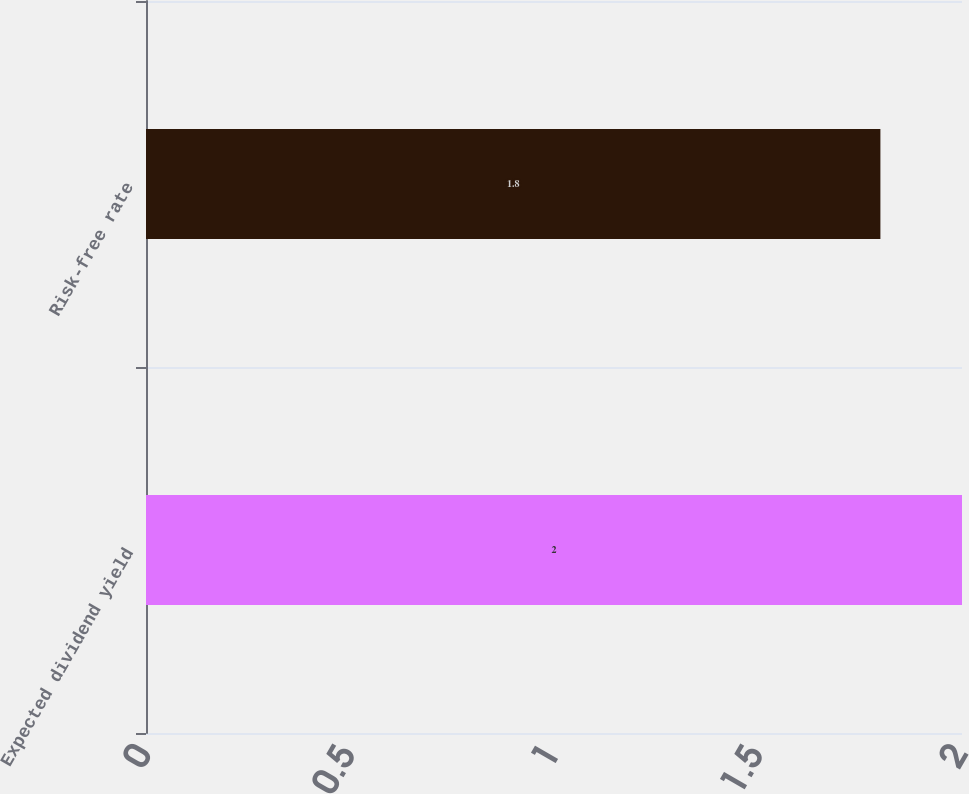<chart> <loc_0><loc_0><loc_500><loc_500><bar_chart><fcel>Expected dividend yield<fcel>Risk-free rate<nl><fcel>2<fcel>1.8<nl></chart> 